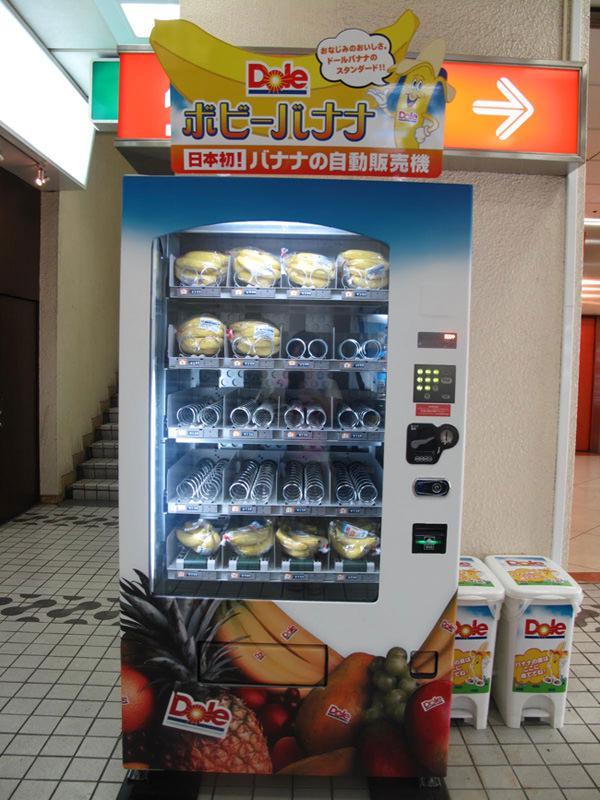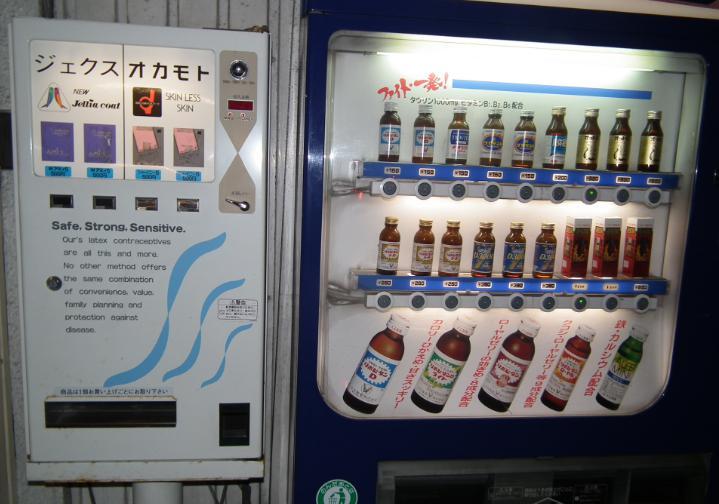The first image is the image on the left, the second image is the image on the right. Assess this claim about the two images: "The left image has a food vending machine, the right image has a beverage vending machine.". Correct or not? Answer yes or no. Yes. The first image is the image on the left, the second image is the image on the right. Evaluate the accuracy of this statement regarding the images: "One photo shows a white vending machine that clearly offers food rather than beverages.". Is it true? Answer yes or no. Yes. The first image is the image on the left, the second image is the image on the right. For the images shown, is this caption "There is a row of red, white, and blue vending machines with pavement in front of them." true? Answer yes or no. No. The first image is the image on the left, the second image is the image on the right. For the images displayed, is the sentence "There are no more than five machines." factually correct? Answer yes or no. Yes. 